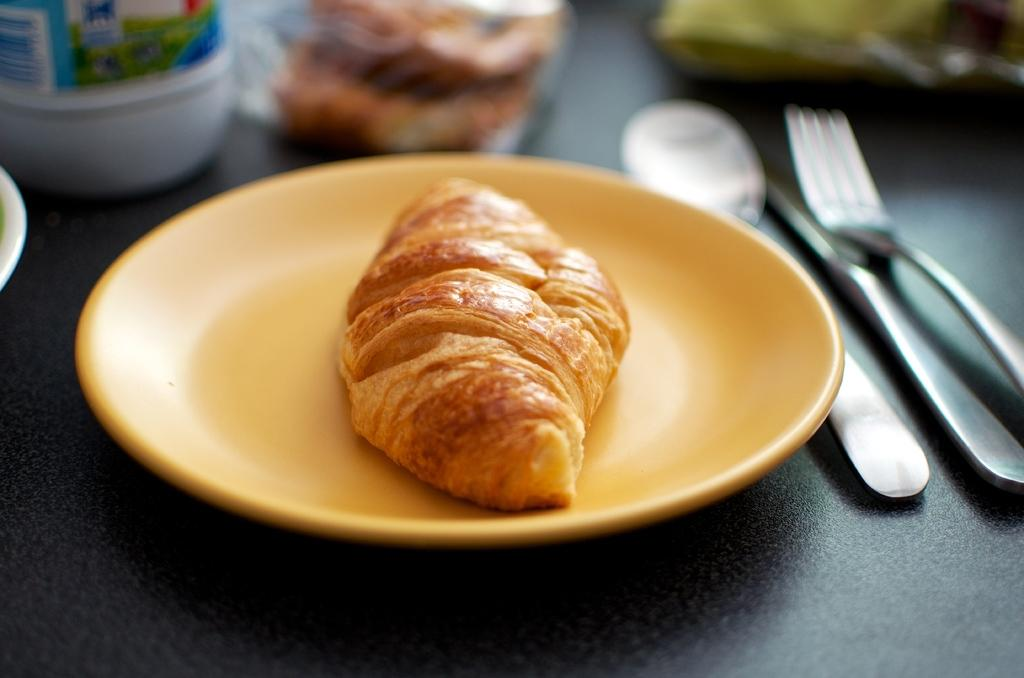What is the main food item visible on the plate in the image? There is a food item on a plate in the image, but the specific type of food cannot be determined from the provided facts. What utensils are present in the image? There is a spoon, a fork, and a knife in the image. Where are these utensils and the food item placed? All these items are placed on a platform. Are there any other objects present in the image besides the food item and utensils? Yes, there are other objects present in the image, but their nature cannot be determined from the provided facts. What type of butter is being used to surprise the women in the image? There is no butter, surprise, or women present in the image. 